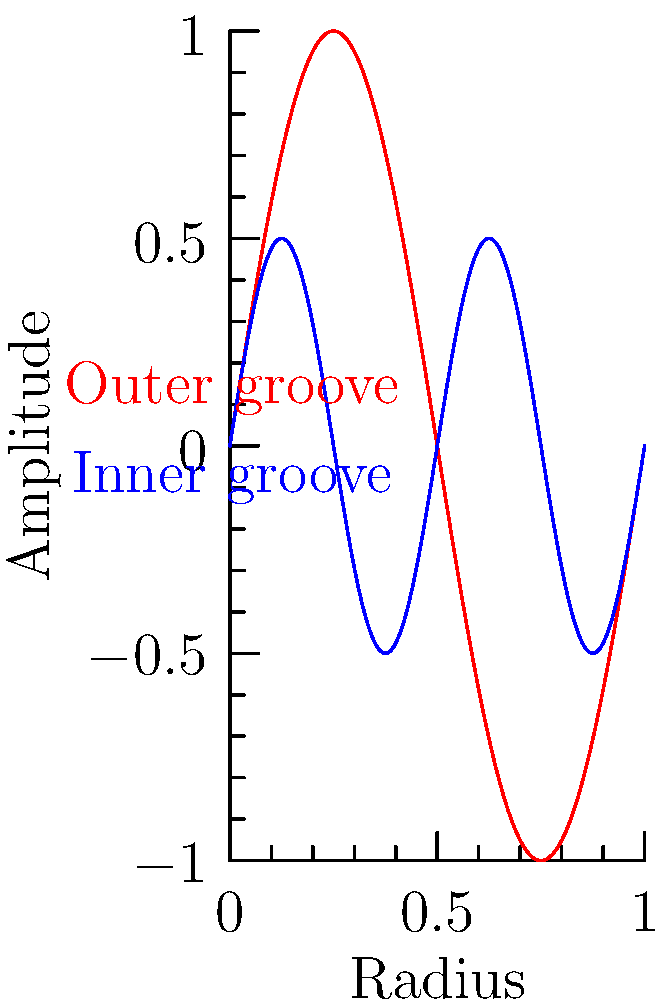Consider a vinyl record with two concentric grooves: an outer groove (red) and an inner groove (blue), as shown in the diagram. The outer groove follows the function $y = \sin(2\pi x)$, while the inner groove follows $y = 0.5\sin(4\pi x)$, where $x$ represents the normalized radius and $y$ the amplitude. What is the genus of the surface formed by these two grooves? To determine the genus of the surface formed by the grooves, we need to follow these steps:

1) First, consider that a vinyl record is topologically equivalent to a disk, which has a genus of 0.

2) Each groove on the record creates a "handle" on this surface. The number of handles determines the genus of the resulting surface.

3) In this case, we have two distinct grooves:
   - The outer groove (red): $y = \sin(2\pi x)$
   - The inner groove (blue): $y = 0.5\sin(4\pi x)$

4) Each of these grooves forms a complete circle around the record, creating one handle each.

5) The genus of a surface is equal to the number of handles. 

6) Therefore, with two grooves, we have two handles.

7) The genus of the resulting surface is thus 2.

This problem relates to your background in music, particularly vinyl records, while also introducing topology concepts relevant to the physical structure of these records.
Answer: 2 